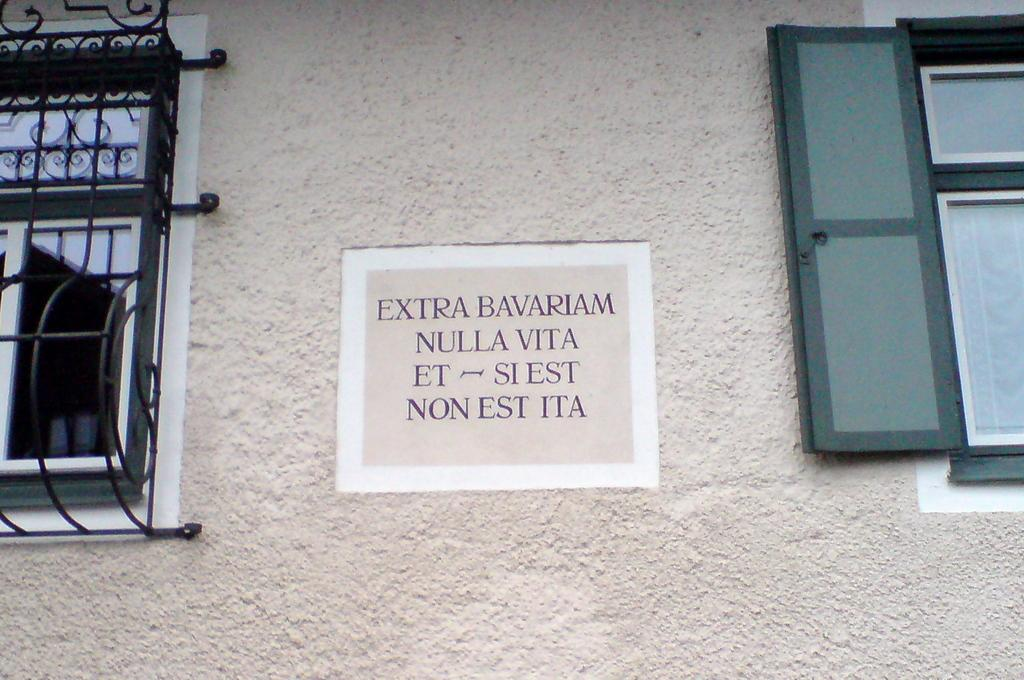What type of structure is visible in the image? There is a wall in the image. Are there any openings in the wall? Yes, there are windows in the image. What can be seen on the wall? There is writing on the wall. What type of ship is depicted in the image? There is no ship present in the image; it only features a wall with windows and writing. What role did the wall play in the war? The provided facts do not mention any war or conflict, so it is impossible to determine the wall's role in a war. 